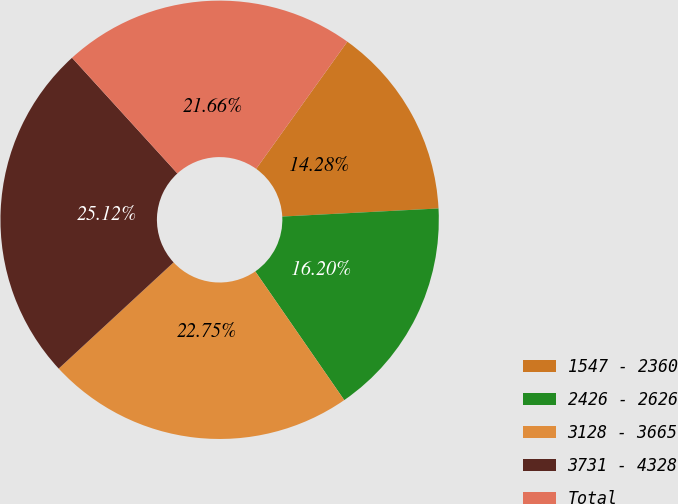Convert chart to OTSL. <chart><loc_0><loc_0><loc_500><loc_500><pie_chart><fcel>1547 - 2360<fcel>2426 - 2626<fcel>3128 - 3665<fcel>3731 - 4328<fcel>Total<nl><fcel>14.28%<fcel>16.2%<fcel>22.75%<fcel>25.12%<fcel>21.66%<nl></chart> 